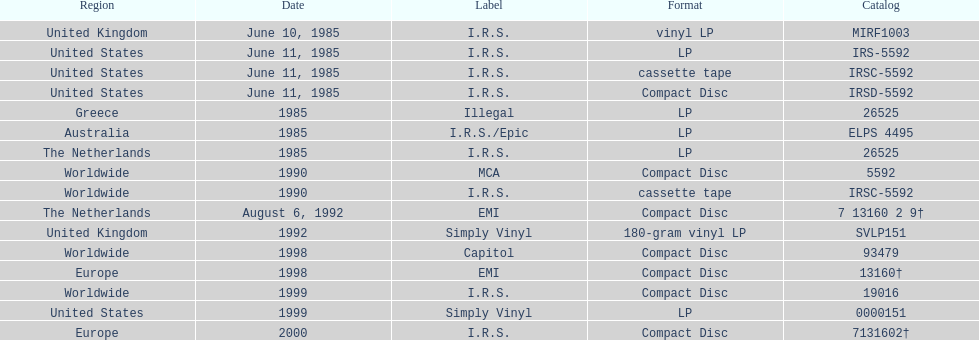What is the sole area with vinyl lp format? United Kingdom. 